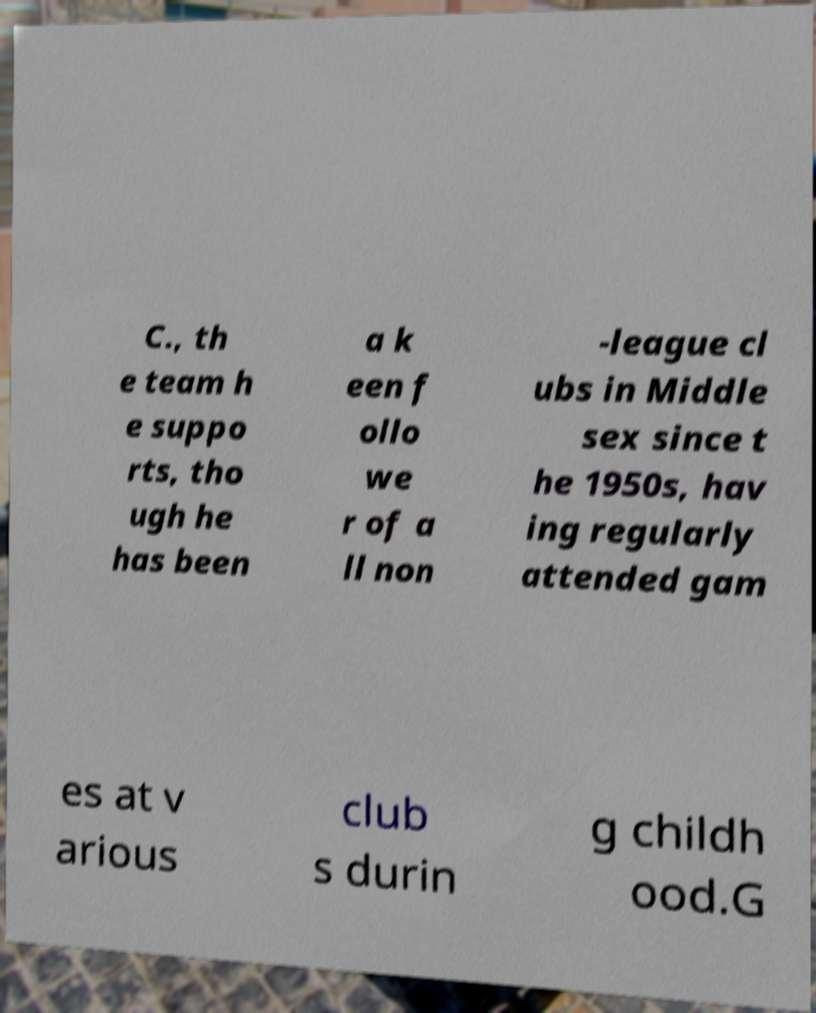Please identify and transcribe the text found in this image. C., th e team h e suppo rts, tho ugh he has been a k een f ollo we r of a ll non -league cl ubs in Middle sex since t he 1950s, hav ing regularly attended gam es at v arious club s durin g childh ood.G 